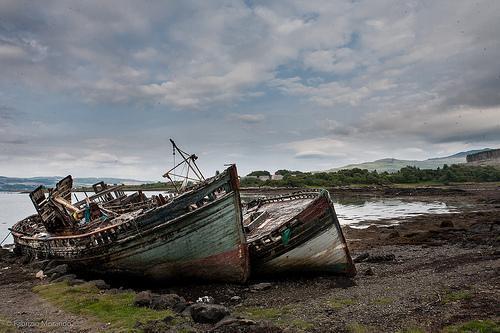How many boats are there?
Give a very brief answer. 2. 